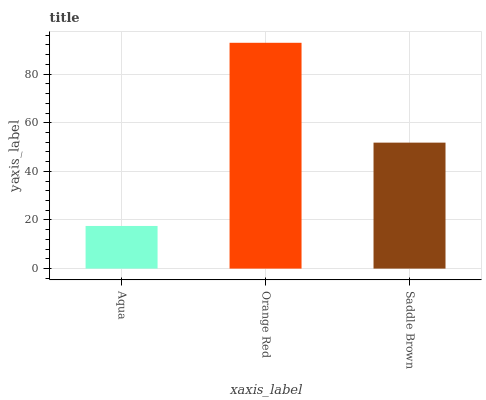Is Aqua the minimum?
Answer yes or no. Yes. Is Orange Red the maximum?
Answer yes or no. Yes. Is Saddle Brown the minimum?
Answer yes or no. No. Is Saddle Brown the maximum?
Answer yes or no. No. Is Orange Red greater than Saddle Brown?
Answer yes or no. Yes. Is Saddle Brown less than Orange Red?
Answer yes or no. Yes. Is Saddle Brown greater than Orange Red?
Answer yes or no. No. Is Orange Red less than Saddle Brown?
Answer yes or no. No. Is Saddle Brown the high median?
Answer yes or no. Yes. Is Saddle Brown the low median?
Answer yes or no. Yes. Is Aqua the high median?
Answer yes or no. No. Is Aqua the low median?
Answer yes or no. No. 